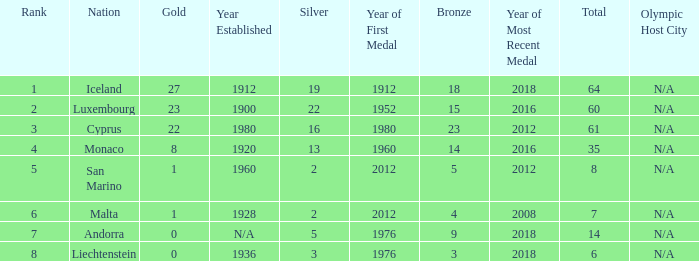Where does Iceland rank with under 19 silvers? None. 